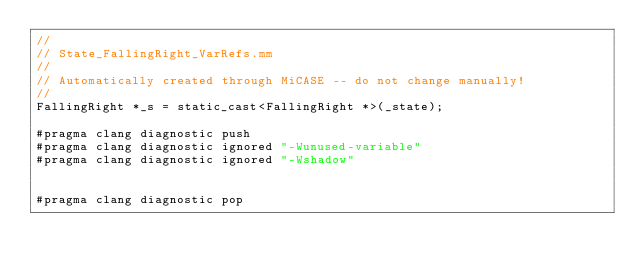<code> <loc_0><loc_0><loc_500><loc_500><_ObjectiveC_>//
// State_FallingRight_VarRefs.mm
//
// Automatically created through MiCASE -- do not change manually!
//
FallingRight *_s = static_cast<FallingRight *>(_state);

#pragma clang diagnostic push
#pragma clang diagnostic ignored "-Wunused-variable"
#pragma clang diagnostic ignored "-Wshadow"


#pragma clang diagnostic pop
</code> 